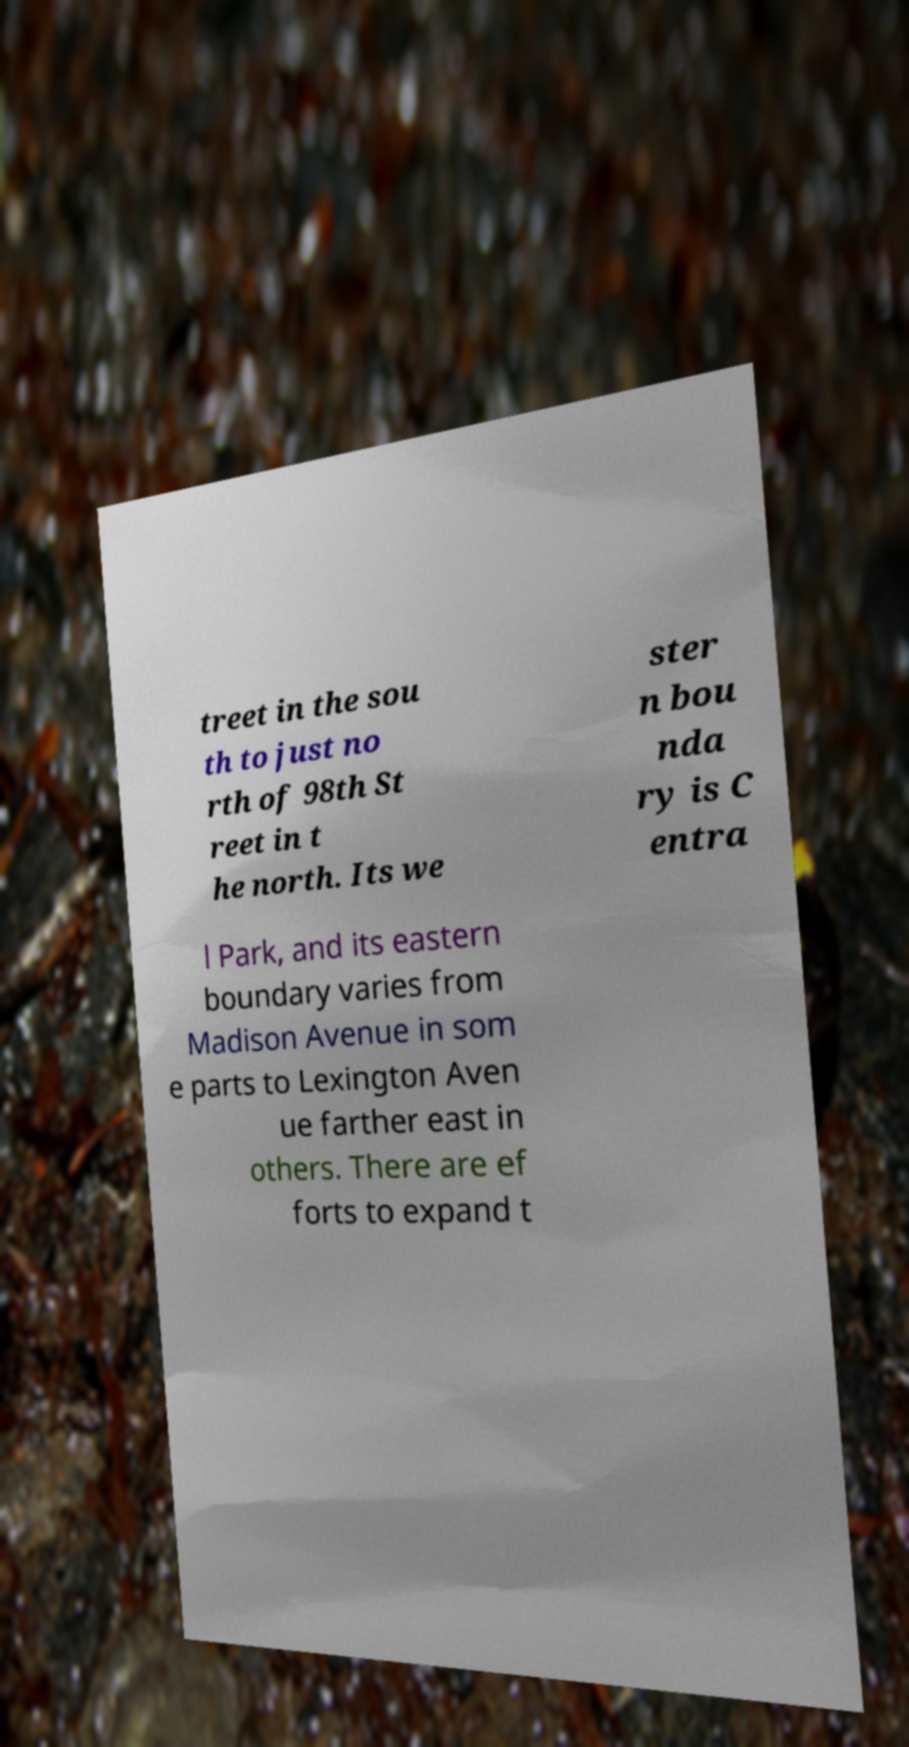Could you extract and type out the text from this image? treet in the sou th to just no rth of 98th St reet in t he north. Its we ster n bou nda ry is C entra l Park, and its eastern boundary varies from Madison Avenue in som e parts to Lexington Aven ue farther east in others. There are ef forts to expand t 